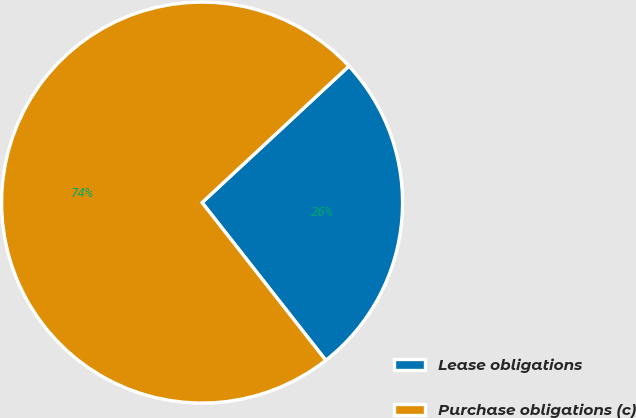Convert chart. <chart><loc_0><loc_0><loc_500><loc_500><pie_chart><fcel>Lease obligations<fcel>Purchase obligations (c)<nl><fcel>26.33%<fcel>73.67%<nl></chart> 